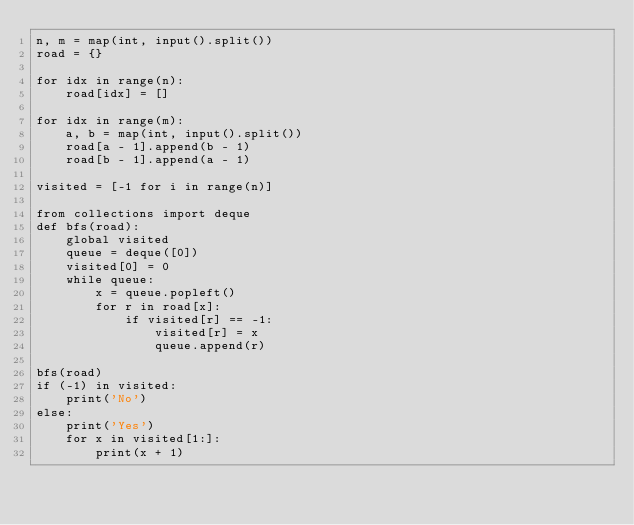Convert code to text. <code><loc_0><loc_0><loc_500><loc_500><_Python_>n, m = map(int, input().split())
road = {}

for idx in range(n):
    road[idx] = []

for idx in range(m):
    a, b = map(int, input().split())
    road[a - 1].append(b - 1)
    road[b - 1].append(a - 1)

visited = [-1 for i in range(n)]

from collections import deque
def bfs(road):
    global visited
    queue = deque([0])
    visited[0] = 0
    while queue:
        x = queue.popleft()
        for r in road[x]:
            if visited[r] == -1:
                visited[r] = x
                queue.append(r)

bfs(road)
if (-1) in visited:
    print('No')
else:
    print('Yes')
    for x in visited[1:]:
        print(x + 1)
</code> 